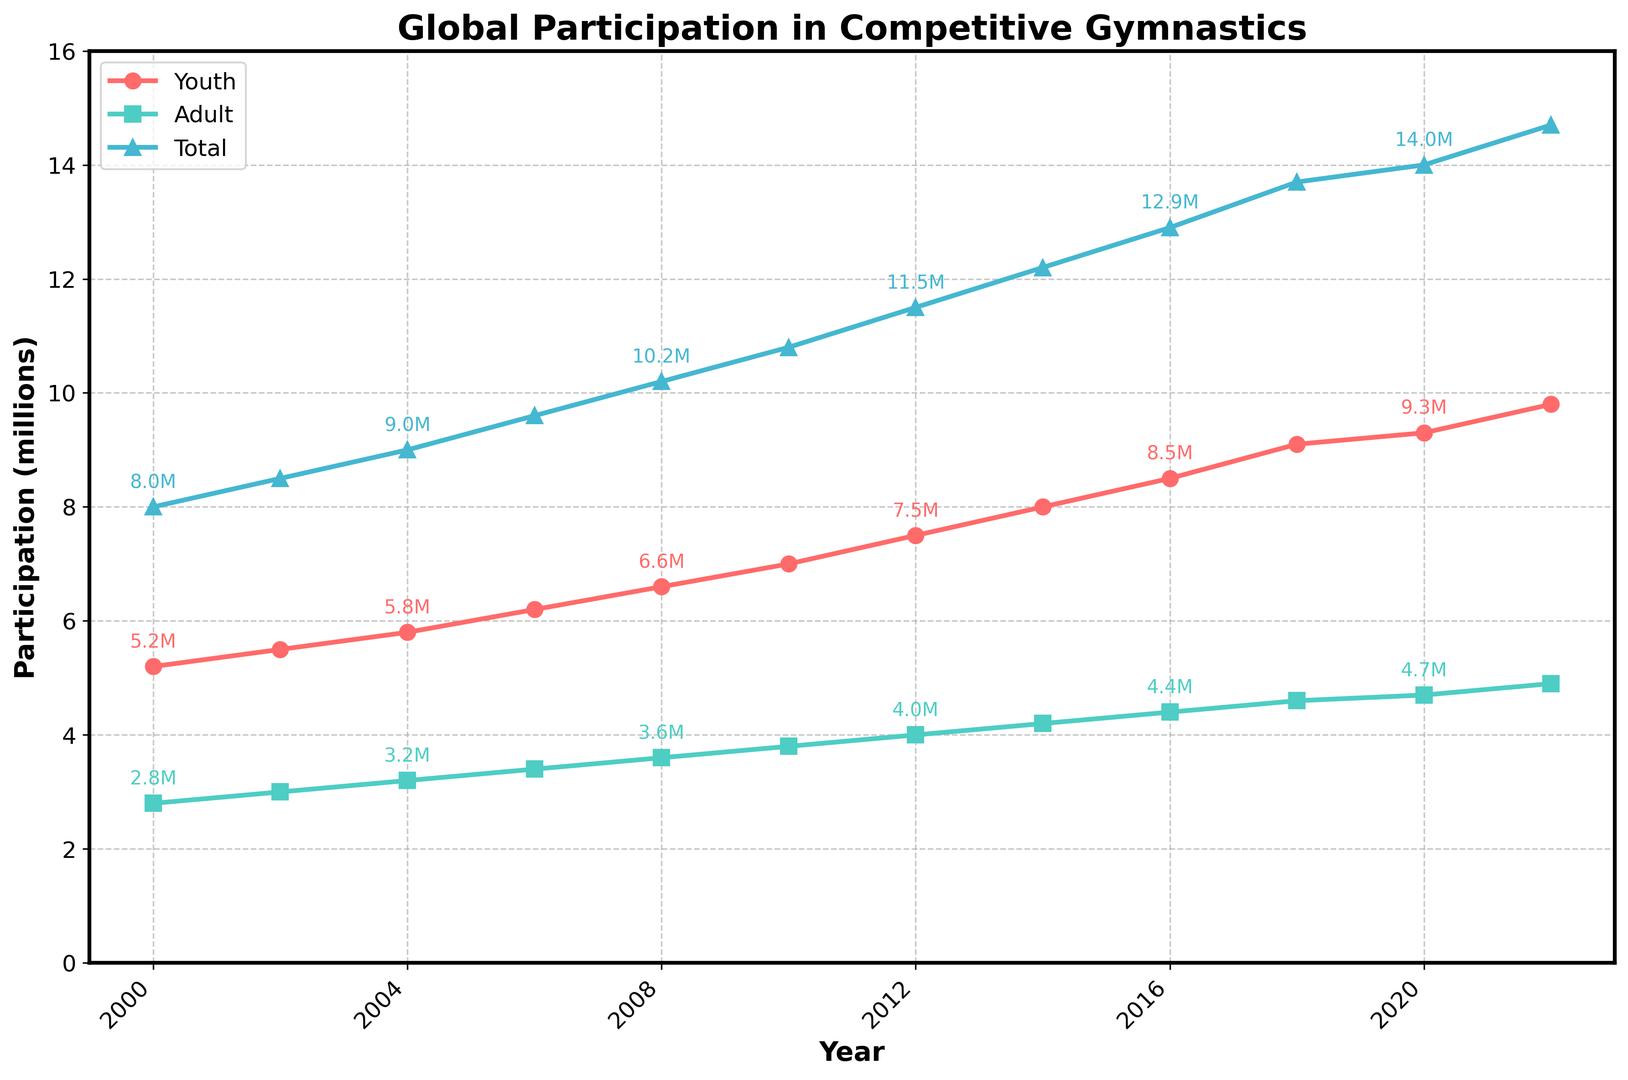What was the trend in youth participation from 2000 to 2022? To assess the trend, we look at the line representing youth participation, which starts at 5.2 million in 2000 and steadily increases each year, reaching 9.8 million in 2022. This shows a consistent upward trend in youth participation over the years.
Answer: Upward trend In which year did total participation in competitive gymnastics first exceed 10 million? We look at the line representing total participation. It exceeds 10 million in 2008, indicated by the marker at that year.
Answer: 2008 How much did adult participation increase between 2000 and 2022? Adult participation in 2000 was 2.8 million and in 2022 was 4.9 million. Subtracting the two values gives the increase: 4.9 - 2.8 = 2.1 million.
Answer: 2.1 million Compare youth and adult participation in 2010. Which group had higher participation, and by how much? In 2010, youth participation was 7.0 million and adult participation was 3.8 million. Youth participation exceeds adult participation by 7.0 - 3.8 = 3.2 million.
Answer: Youth by 3.2 million What is the total participation growth from 2006 to 2016? Total participation in 2006 was 9.6 million, and in 2016 it was 12.9 million. The growth is 12.9 - 9.6 = 3.3 million.
Answer: 3.3 million Between which consecutive years did youth participation experience the largest increase? To find the largest increase, check the differences between consecutive years: 2000-2002 (0.3 million), 2002-2004 (0.3 million), 2004-2006 (0.4 million), 2006-2008 (0.4 million), 2008-2010 (0.4 million), 2010-2012 (0.5 million), 2012-2014 (0.5 million), 2014-2016 (0.5 million), 2016-2018 (0.6 million), 2018-2020 (0.2 million), 2020-2022 (0.5 million). The largest increase is between 2016-2018.
Answer: 2016-2018 What's the ratio of youth participation to total participation in 2022? In 2022, youth participation is 9.8 million and total participation is 14.7 million. The ratio is 9.8 / 14.7 ≈ 0.67.
Answer: 0.67 How does the adult participation trend compare to the youth participation trend over the years? Both youth and adult participations show an increasing trend from 2000 to 2022. However, youth participation increases more steeply compared to adult participation, as indicated by the sharper slope of the youth line.
Answer: Both increase, youth more steeply 